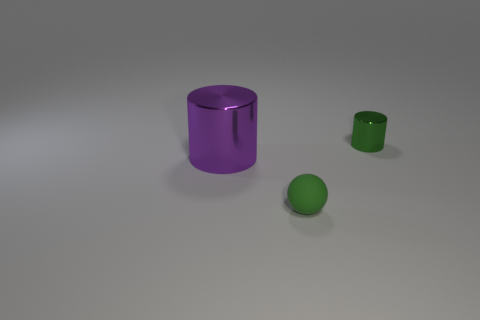Can you explain the lighting source in this scene? Certainly. The scene is illuminated with what seems to be a soft, diffuse overhead light, as indicated by the soft shadows under the objects. There's no harsh shadowing or bright highlights, suggesting that the light source is not very close to the objects. 